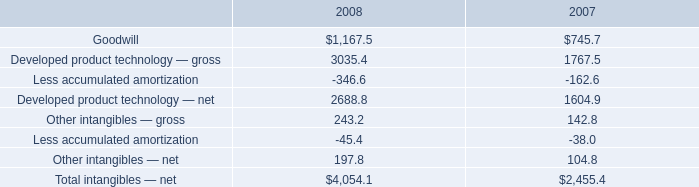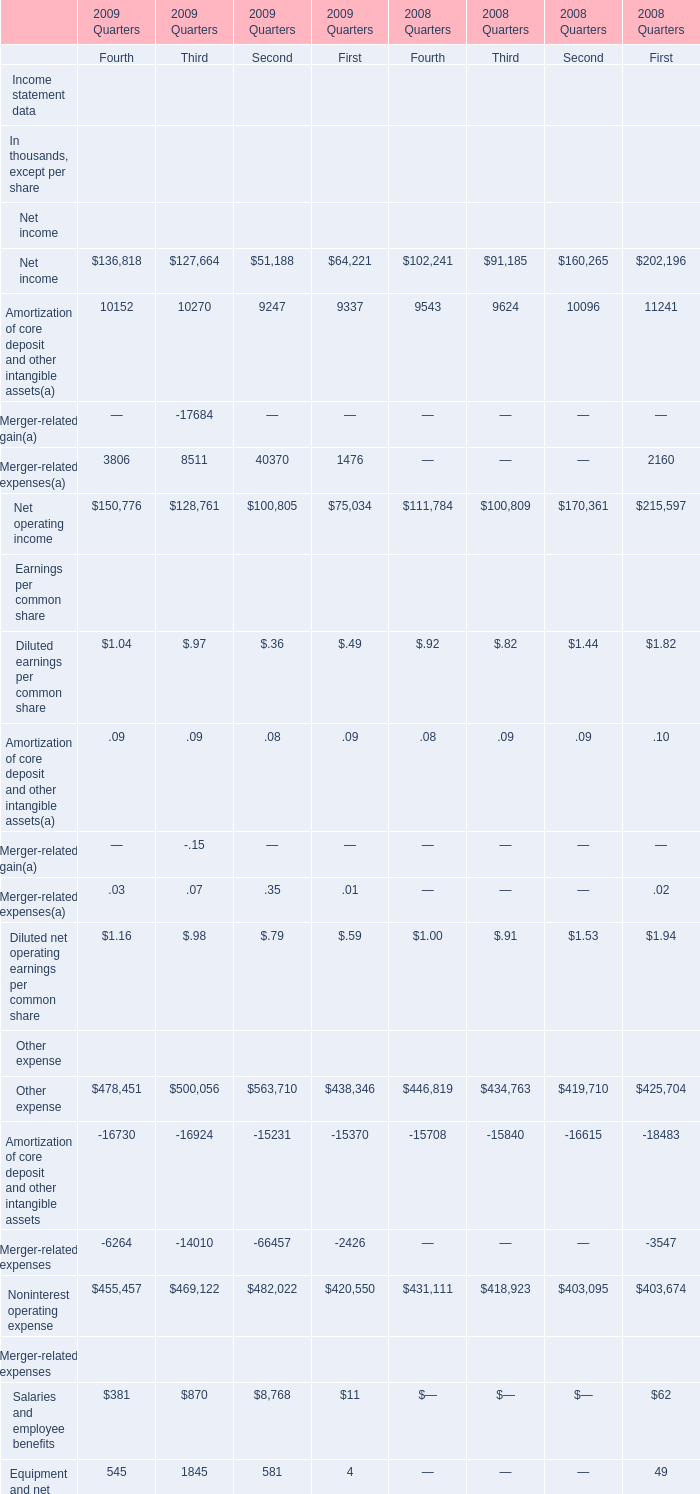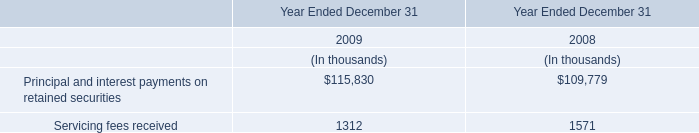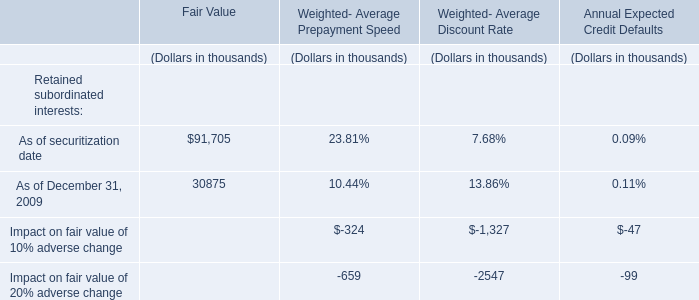What is the total amount of Noninterest operating expense Other expense of 2009 Quarters First, and Developed product technology — gross of 2007 ? 
Computations: (420550.0 + 1767.5)
Answer: 422317.5. 